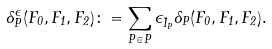Convert formula to latex. <formula><loc_0><loc_0><loc_500><loc_500>\Lambda ^ { \epsilon } _ { P } ( F _ { 0 } , F _ { 1 } , F _ { 2 } ) \colon = \sum _ { P \in P } \epsilon _ { \vec { I } _ { P } } \Lambda _ { P } ( F _ { 0 } , F _ { 1 } , F _ { 2 } ) .</formula> 